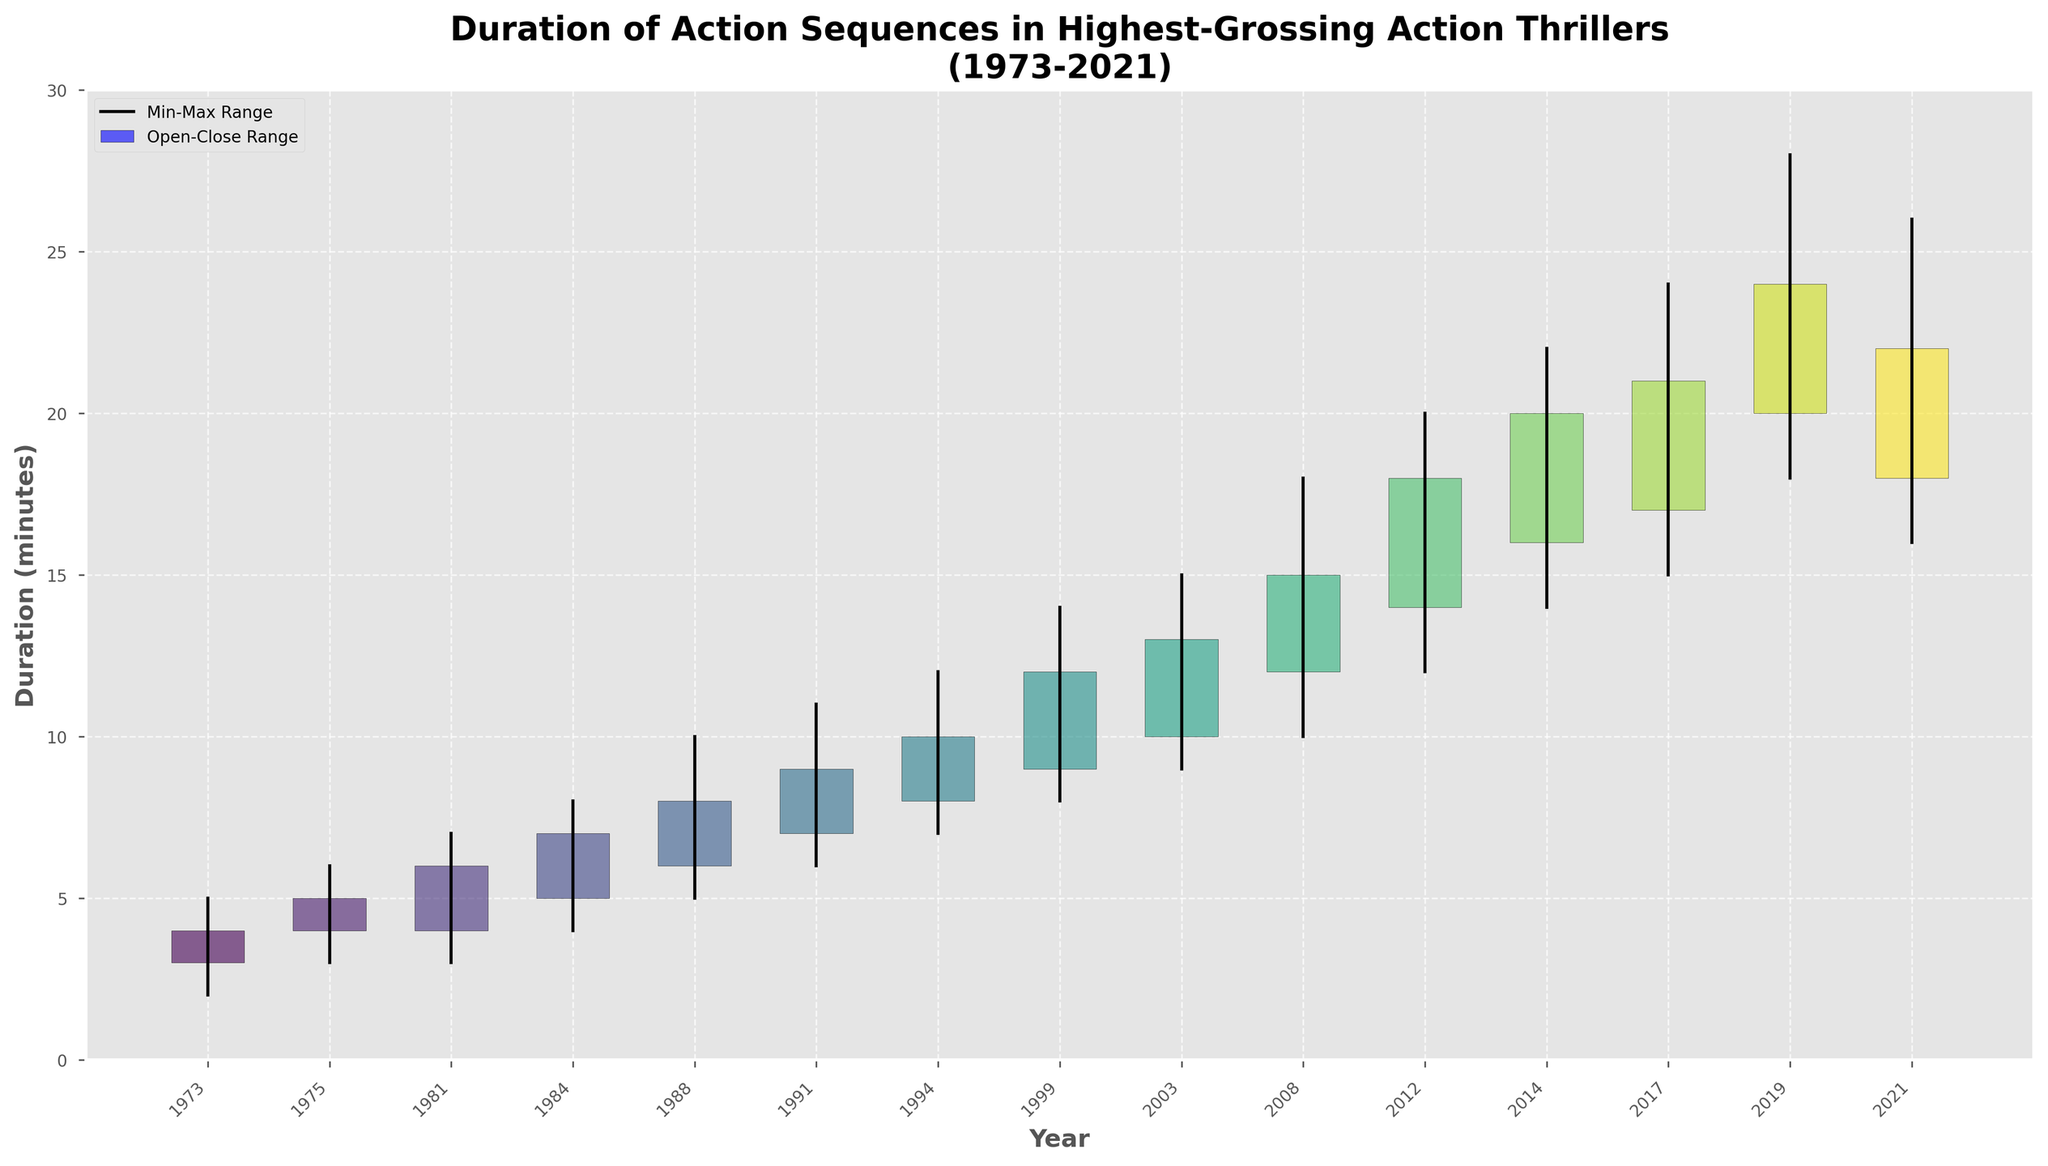What's the title of the figure? The title of the figure is displayed at the top and reads 'Duration of Action Sequences in Highest-Grossing Action Thrillers (1973-2021)'.
Answer: Duration of Action Sequences in Highest-Grossing Action Thrillers (1973-2021) Which year shows the longest max duration of action sequences? By looking at the vertical lines representing the max duration, 2019 shows the longest line, indicating the longest max duration.
Answer: 2019 Which movie has a greater open duration than close duration? The color red in rectangles signifies that the open duration is greater than the close duration. Looking at the plot, only the year 2021 has this characteristic.
Answer: No Time to Die (2021) How many movies in this plot have min durations of 10 minutes or more? By observing the bottom endpoints of the vertical lines, we identify that there are four movies with min durations of 10 minutes or more: The Dark Knight (2008), The Avengers (2012), John Wick (2014), and Avengers: Endgame (2019).
Answer: 4 What's the difference between the max and min durations for 'The Matrix'? The max duration for 'The Matrix' (1999) is 14 minutes, and the min duration is 8 minutes. The difference is 14 - 8.
Answer: 6 Which movie represents the largest increase in duration from open to close? The height of the rectangles symbolizes the increase. 'Avengers: Endgame' (2019) has the tallest blue rectangle, representing the largest increase from open to close.
Answer: Avengers: Endgame (2019) Does the duration of action sequences generally increase over time? By observing the general trend and heights of the rectangles over years, we can see an overall increasing trend from 1973 to 2021.
Answer: Yes Which movie's max duration is the closest to its close duration? By evaluating the closeness of the top end of the rectangle to the top end of the vertical line, 'The Avengers' (2012) has the max duration very close to its close duration.
Answer: The Avengers (2012) What's the average duration of open durations for the movies in the 1980s? Movies from the 1980s are 'Indiana Jones: Raiders of the Lost Ark' (1981) and 'The Terminator' (1984). The open durations are 4 and 5. The average is (4+5)/2.
Answer: 4.5 Which movies have open durations of exactly 14 minutes or more? By looking at the lower end of the rectangles and identifying those starting at 14 or higher, the movies are 'The Avengers' (2012), 'John Wick' (2014), 'Wonder Woman' (2017), 'Avengers: Endgame' (2019), and 'No Time to Die' (2021).
Answer: 5 